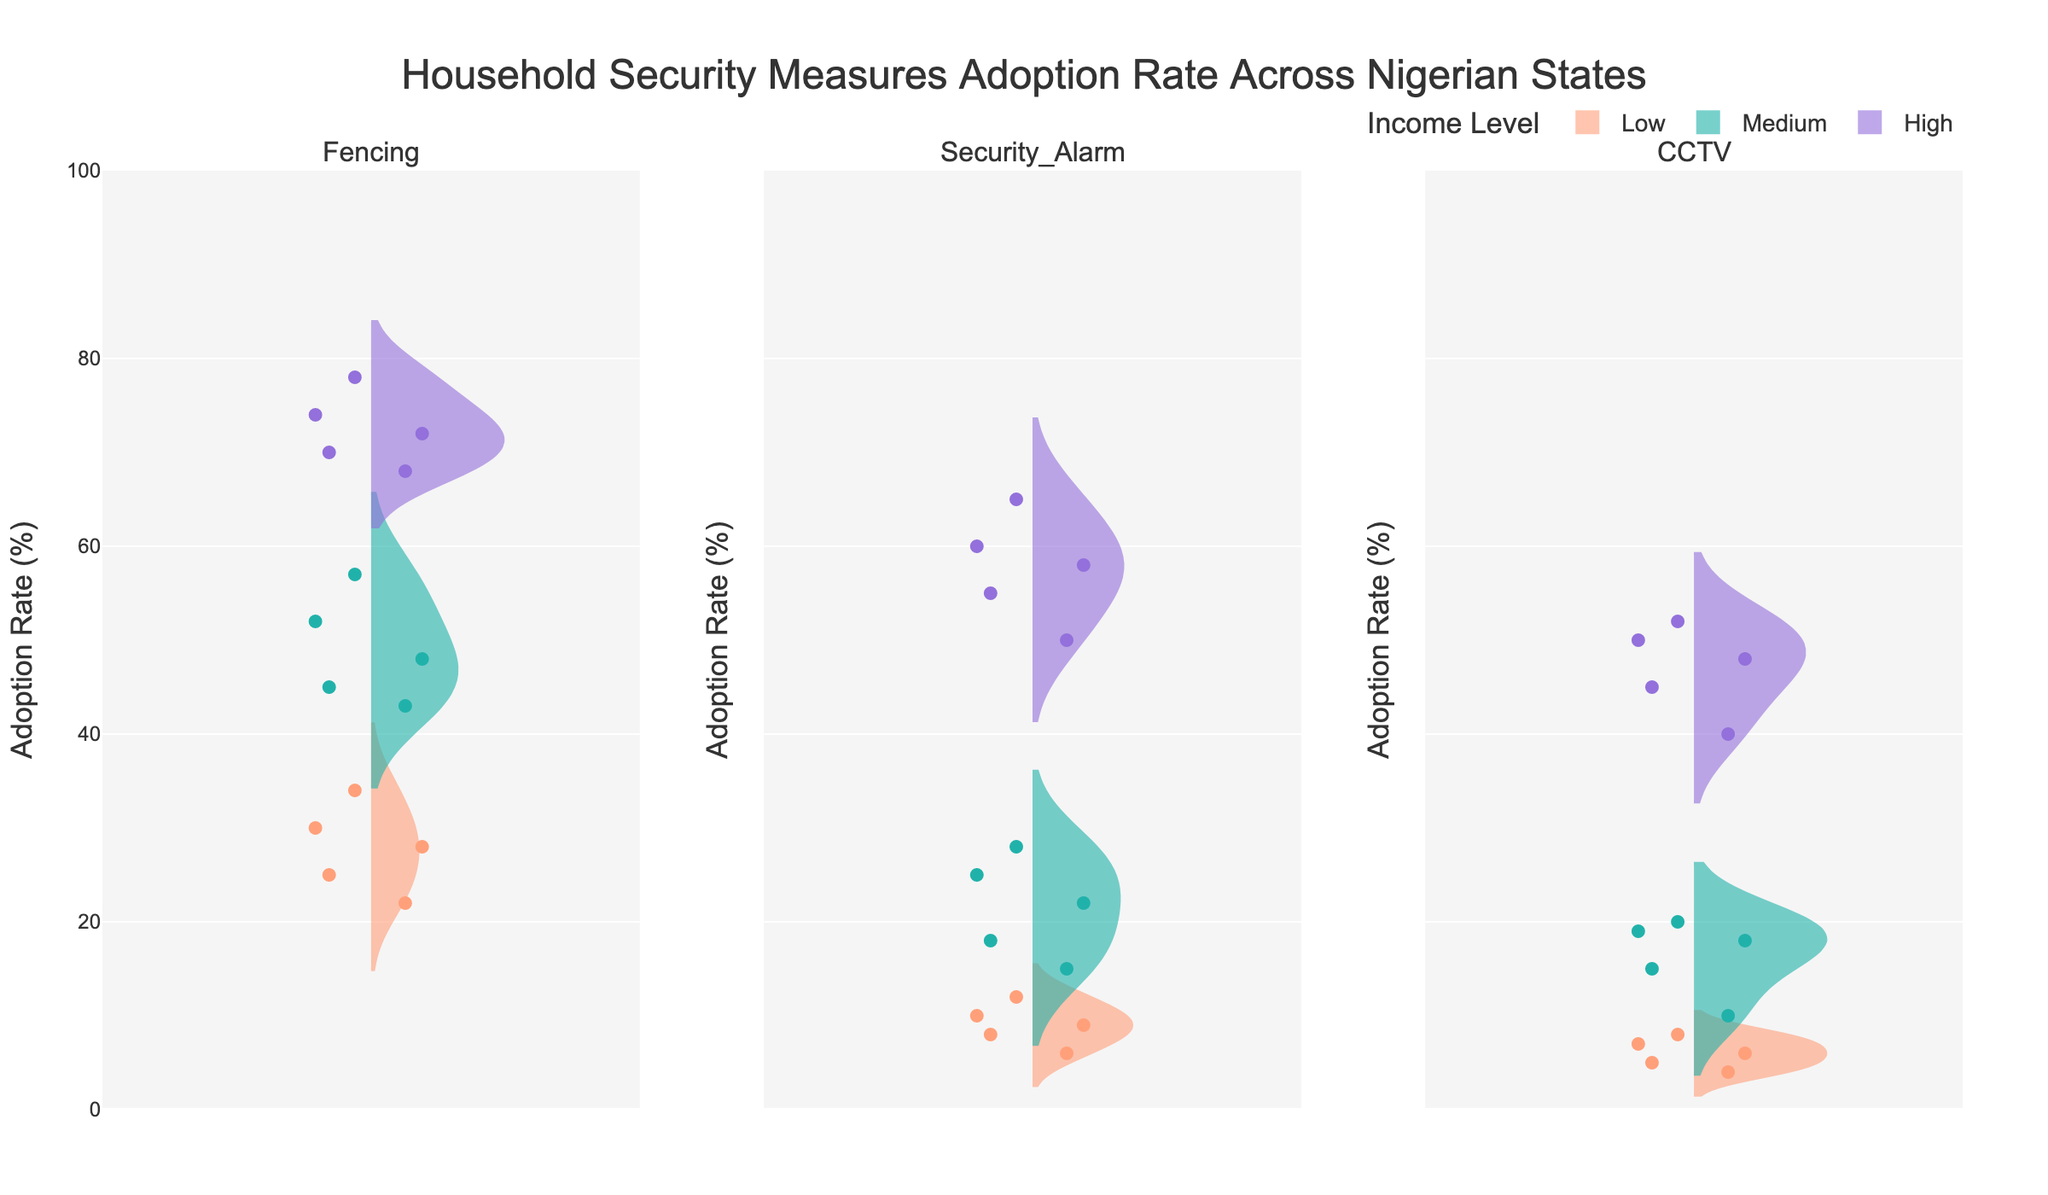What is the overall adoption rate of fencing for low-income households across all states? To find the overall adoption rate, we need to consider the adoption rates of fencing for low-income households in each state and then take an average. The rates are: Lagos (34%), Kano (25%), Enugu (30%), Rivers (28%), and Kaduna (22%). Summing these rates gives 34 + 25 + 30 + 28 + 22 = 139. Dividing by the number of states, which is 5, gives 139 / 5 = 27.8%.
Answer: 27.8% Which household income level shows the highest adoption rate of CCTV in Lagos? By looking at the adoption rates of CCTV in Lagos for each income level, we have Low (8%), Medium (20%), and High (50%). The highest adoption rate is for high-income households, which is 50%.
Answer: High Compare the adoption rate of security alarms in Rivers for medium and high-income households. Which is higher and by how much? The adoption rates of security alarms in Rivers are 22% for medium-income and 58% for high-income households. The difference between these two rates is 58 - 22 = 36%. Thus, the adoption rate is higher for high-income households by 36%.
Answer: High by 36% What is the total number of security measures recorded in the data? To find the total number of security measures recorded, we look at the unique security measures: Fencing, Security Alarm, and CCTV. Identifying these, we find there are 3 unique measures.
Answer: 3 Which state has the highest adoption rate for fencing among high-income households and what is the rate? By examining the adoption rates of fencing among high-income households across all states, we find the rates are: Lagos (78%), Kano (70%), Enugu (74%), Rivers (72%), and Kaduna (68%). Lagos has the highest adoption rate of 78%.
Answer: Lagos, 78% How does the adoption rate of security alarms for high-income households in Kano compare to that in Kaduna? The adoption rates of security alarms for high-income households are 55% in Kano and 50% in Kaduna. Comparing these, Kano has a 5% higher adoption rate than Kaduna.
Answer: Kano is higher by 5% What is the average adoption rate of CCTV across all income levels in Enugu? The adoption rates of CCTV in Enugu are Low (6%), Medium (18%), and High (52%). To find the average, we sum these rates: 6 + 18 + 52 = 76%. Dividing by 3 gives an average adoption rate of 76 / 3 ≈ 25.33%.
Answer: 25.33% How many jittered points would you expect to see for the medium-income level in the Security Alarm category across all states? Each state has one data point for medium-income level in the Security Alarm category. Since there are 5 states, there would be 5 jittered points.
Answer: 5 In which state do medium-income households have the highest adoption rate of fencing? The adoption rates of fencing among medium-income households are: Lagos (57%), Kano (45%), Enugu (52%), Rivers (48%), and Kaduna (43%). Lagos has the highest adoption rate of 57%.
Answer: Lagos, 57% What percentage difference is there between the highest and lowest adoption rate of security alarms for low-income households? The adoption rates of security alarms for low-income households are: Lagos (12%), Kano (8%), Enugu (10%), Rivers (9%), and Kaduna (6%). The highest rate is 12% (Lagos) and the lowest is 6% (Kaduna). The difference is 12 - 6 = 6%.
Answer: 6% 